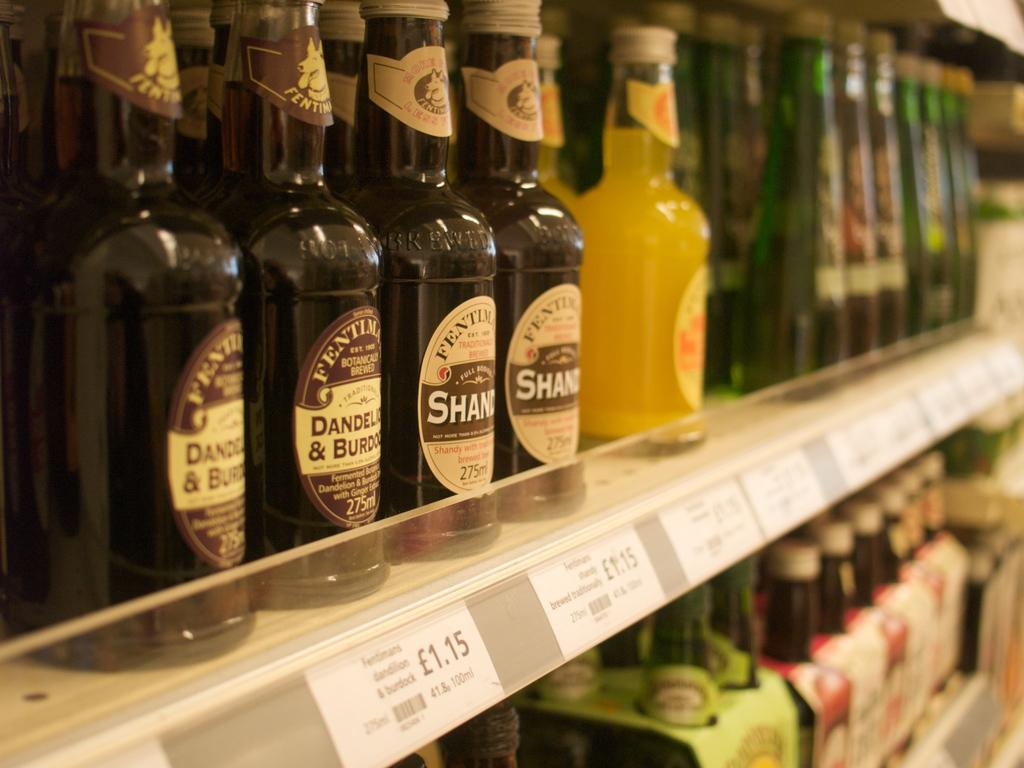<image>
Share a concise interpretation of the image provided. One bottle of beer costs 1.15 pounds at this store. 